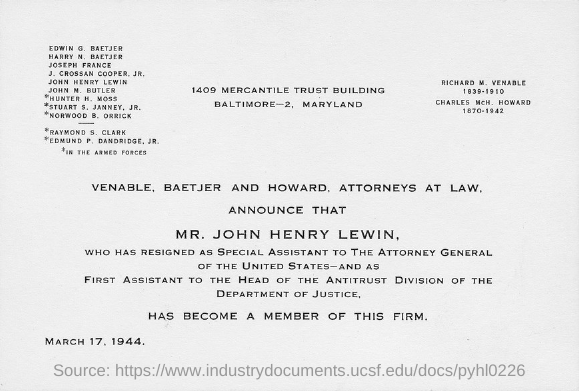Who has resigned as a special assistant to the attorney General of the United States?
Give a very brief answer. Mr. John Henry Lewin. What is the Date?
Your response must be concise. March 17, 1944. 